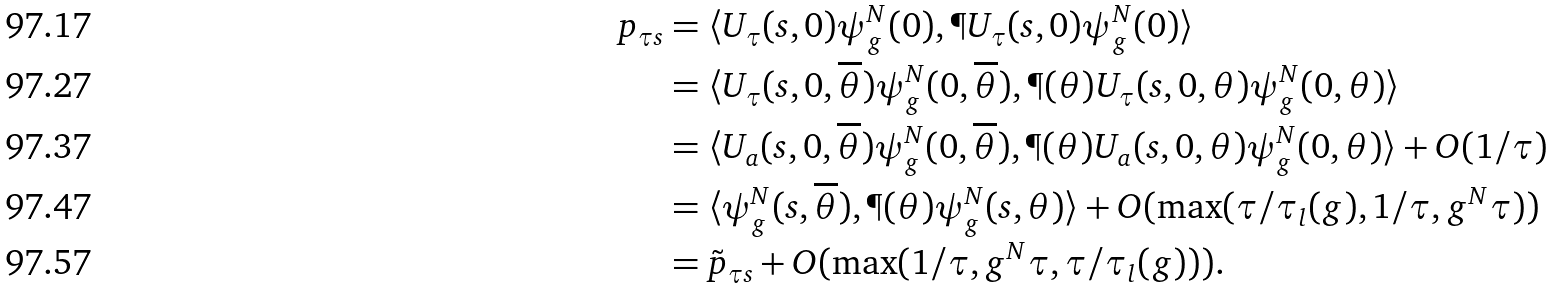Convert formula to latex. <formula><loc_0><loc_0><loc_500><loc_500>p _ { \tau s } & = \langle U _ { \tau } ( s , 0 ) \psi _ { g } ^ { N } ( 0 ) , \P U _ { \tau } ( s , 0 ) \psi _ { g } ^ { N } ( 0 ) \rangle \\ & = \langle U _ { \tau } ( s , 0 , \overline { \theta } ) \psi _ { g } ^ { N } ( 0 , \overline { \theta } ) , \P ( \theta ) U _ { \tau } ( s , 0 , \theta ) \psi _ { g } ^ { N } ( 0 , \theta ) \rangle \\ & = \langle U _ { a } ( s , 0 , \overline { \theta } ) \psi _ { g } ^ { N } ( 0 , \overline { \theta } ) , \P ( \theta ) U _ { a } ( s , 0 , \theta ) \psi _ { g } ^ { N } ( 0 , \theta ) \rangle + O ( 1 / \tau ) \\ & = \langle \psi _ { g } ^ { N } ( s , \overline { \theta } ) , \P ( \theta ) \psi _ { g } ^ { N } ( s , \theta ) \rangle + O ( \max ( \tau / \tau _ { l } ( g ) , 1 / \tau , g ^ { N } \tau ) ) \\ & = \tilde { p } _ { \tau s } + O ( \max ( 1 / \tau , g ^ { N } \tau , \tau / \tau _ { l } ( g ) ) ) .</formula> 